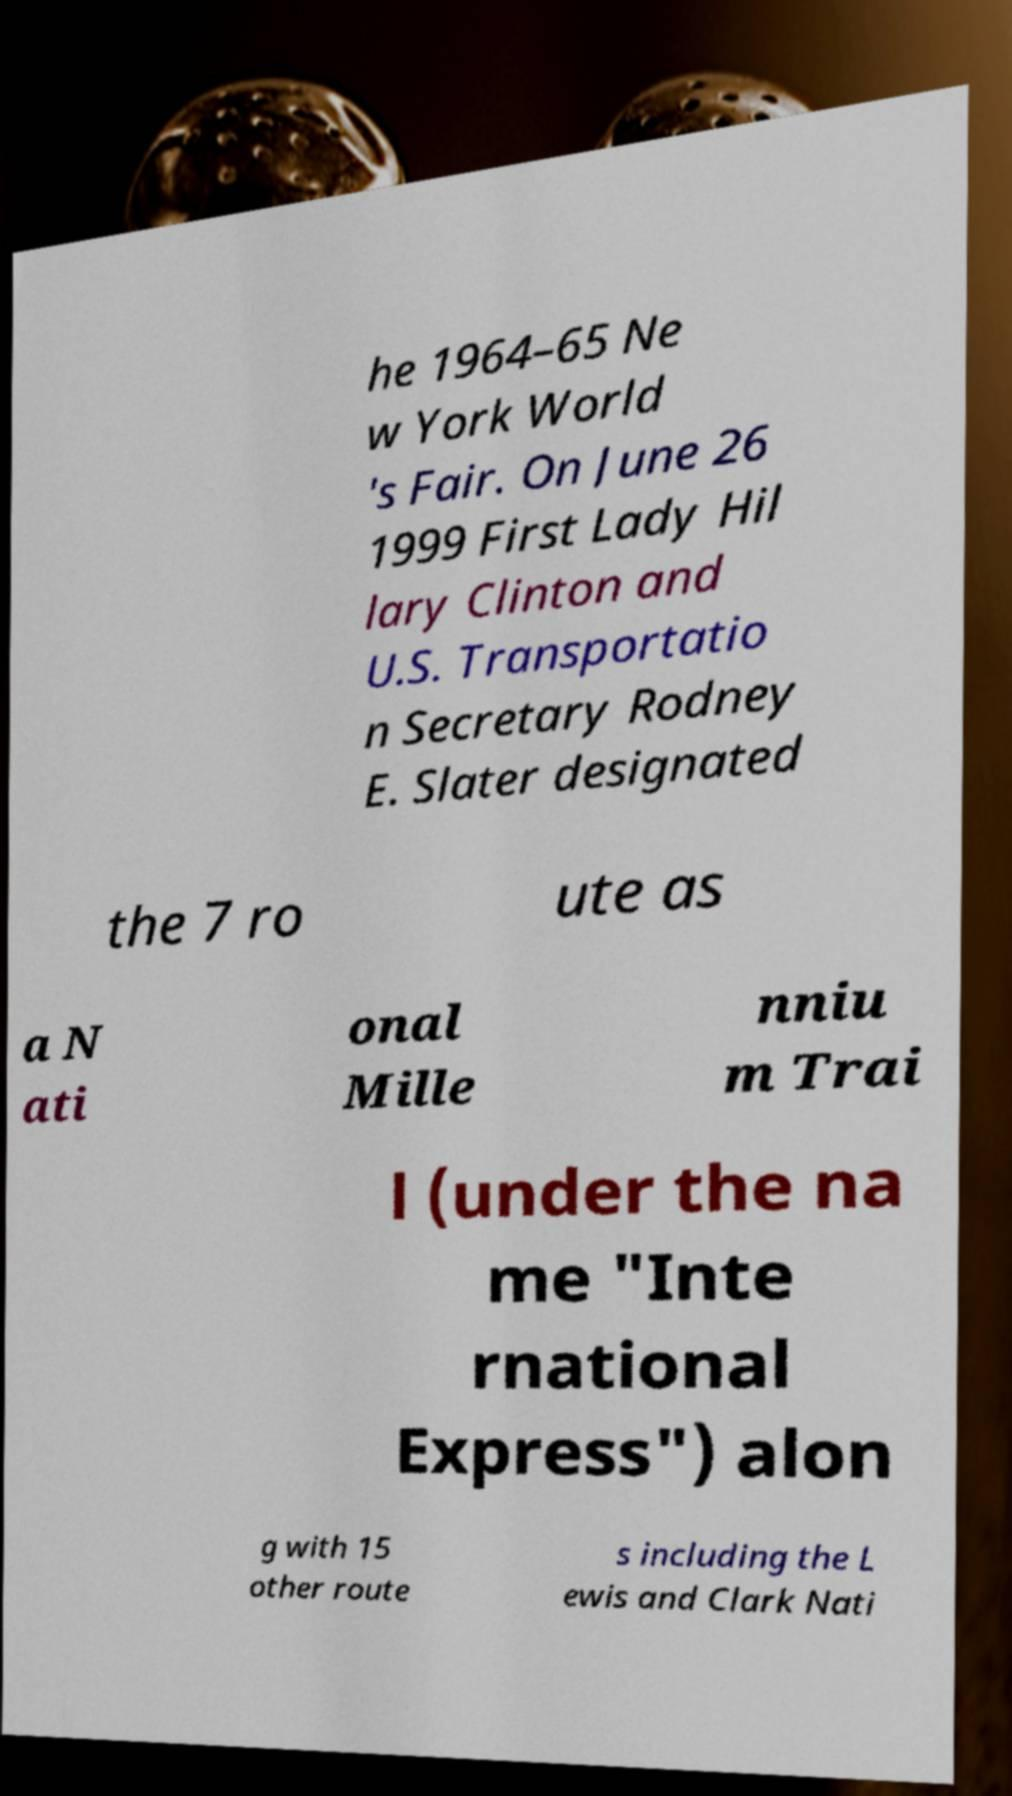Can you accurately transcribe the text from the provided image for me? he 1964–65 Ne w York World 's Fair. On June 26 1999 First Lady Hil lary Clinton and U.S. Transportatio n Secretary Rodney E. Slater designated the 7 ro ute as a N ati onal Mille nniu m Trai l (under the na me "Inte rnational Express") alon g with 15 other route s including the L ewis and Clark Nati 